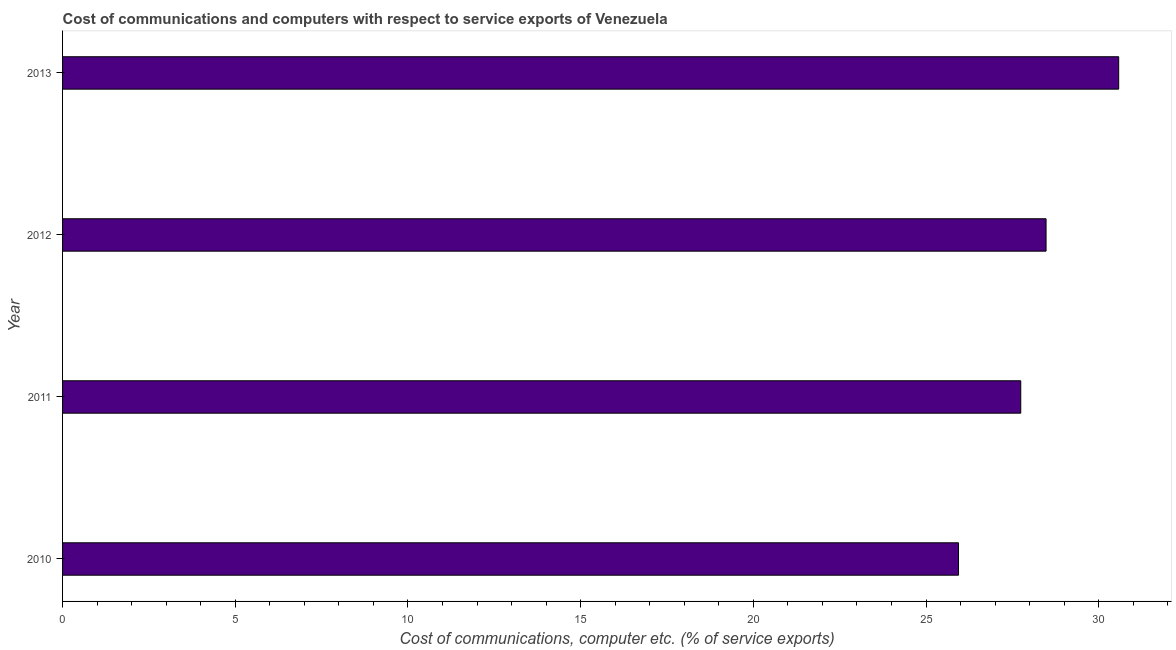Does the graph contain any zero values?
Offer a very short reply. No. Does the graph contain grids?
Ensure brevity in your answer.  No. What is the title of the graph?
Offer a very short reply. Cost of communications and computers with respect to service exports of Venezuela. What is the label or title of the X-axis?
Give a very brief answer. Cost of communications, computer etc. (% of service exports). What is the label or title of the Y-axis?
Ensure brevity in your answer.  Year. What is the cost of communications and computer in 2011?
Give a very brief answer. 27.74. Across all years, what is the maximum cost of communications and computer?
Your answer should be compact. 30.58. Across all years, what is the minimum cost of communications and computer?
Provide a succinct answer. 25.94. In which year was the cost of communications and computer minimum?
Provide a short and direct response. 2010. What is the sum of the cost of communications and computer?
Your answer should be very brief. 112.73. What is the difference between the cost of communications and computer in 2010 and 2013?
Make the answer very short. -4.64. What is the average cost of communications and computer per year?
Offer a terse response. 28.18. What is the median cost of communications and computer?
Keep it short and to the point. 28.11. Is the cost of communications and computer in 2012 less than that in 2013?
Keep it short and to the point. Yes. What is the difference between the highest and the second highest cost of communications and computer?
Give a very brief answer. 2.1. Is the sum of the cost of communications and computer in 2010 and 2011 greater than the maximum cost of communications and computer across all years?
Give a very brief answer. Yes. What is the difference between the highest and the lowest cost of communications and computer?
Offer a very short reply. 4.64. In how many years, is the cost of communications and computer greater than the average cost of communications and computer taken over all years?
Offer a very short reply. 2. How many bars are there?
Provide a short and direct response. 4. Are all the bars in the graph horizontal?
Provide a succinct answer. Yes. What is the difference between two consecutive major ticks on the X-axis?
Your response must be concise. 5. Are the values on the major ticks of X-axis written in scientific E-notation?
Your answer should be very brief. No. What is the Cost of communications, computer etc. (% of service exports) of 2010?
Provide a succinct answer. 25.94. What is the Cost of communications, computer etc. (% of service exports) of 2011?
Ensure brevity in your answer.  27.74. What is the Cost of communications, computer etc. (% of service exports) in 2012?
Your answer should be very brief. 28.47. What is the Cost of communications, computer etc. (% of service exports) in 2013?
Offer a terse response. 30.58. What is the difference between the Cost of communications, computer etc. (% of service exports) in 2010 and 2011?
Your response must be concise. -1.8. What is the difference between the Cost of communications, computer etc. (% of service exports) in 2010 and 2012?
Ensure brevity in your answer.  -2.53. What is the difference between the Cost of communications, computer etc. (% of service exports) in 2010 and 2013?
Provide a short and direct response. -4.64. What is the difference between the Cost of communications, computer etc. (% of service exports) in 2011 and 2012?
Your answer should be compact. -0.73. What is the difference between the Cost of communications, computer etc. (% of service exports) in 2011 and 2013?
Give a very brief answer. -2.84. What is the difference between the Cost of communications, computer etc. (% of service exports) in 2012 and 2013?
Offer a very short reply. -2.1. What is the ratio of the Cost of communications, computer etc. (% of service exports) in 2010 to that in 2011?
Offer a terse response. 0.94. What is the ratio of the Cost of communications, computer etc. (% of service exports) in 2010 to that in 2012?
Offer a very short reply. 0.91. What is the ratio of the Cost of communications, computer etc. (% of service exports) in 2010 to that in 2013?
Ensure brevity in your answer.  0.85. What is the ratio of the Cost of communications, computer etc. (% of service exports) in 2011 to that in 2012?
Offer a very short reply. 0.97. What is the ratio of the Cost of communications, computer etc. (% of service exports) in 2011 to that in 2013?
Give a very brief answer. 0.91. 